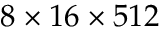<formula> <loc_0><loc_0><loc_500><loc_500>8 \times 1 6 \times 5 1 2</formula> 